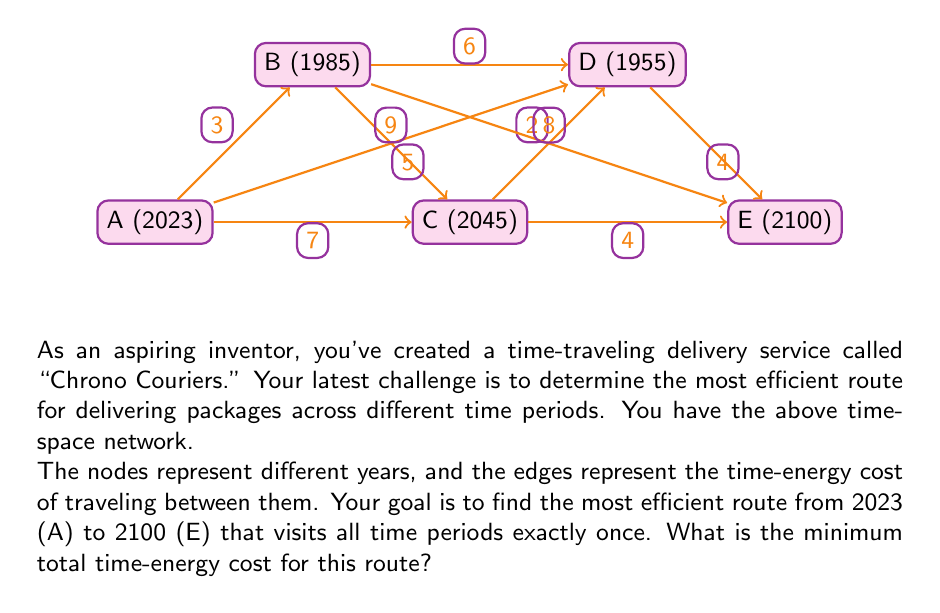Can you answer this question? To solve this problem, we need to find the Hamiltonian path with the minimum cost from A to E that visits all nodes exactly once. This is a variation of the Traveling Salesman Problem (TSP).

Given the small number of nodes, we can solve this using a brute-force approach by examining all possible paths:

1. List all possible paths from A to E visiting all nodes:
   - A -> B -> C -> D -> E
   - A -> B -> D -> C -> E
   - A -> C -> B -> D -> E
   - A -> C -> D -> B -> E
   - A -> D -> B -> C -> E
   - A -> D -> C -> B -> E

2. Calculate the cost for each path:
   - A -> B -> C -> D -> E: 3 + 5 + 2 + 4 = 14
   - A -> B -> D -> C -> E: 3 + 6 + 2 + 4 = 15
   - A -> C -> B -> D -> E: 7 + 5 + 6 + 4 = 22
   - A -> C -> D -> B -> E: 7 + 2 + 6 + 8 = 23
   - A -> D -> B -> C -> E: 9 + 6 + 5 + 4 = 24
   - A -> D -> C -> B -> E: 9 + 2 + 5 + 8 = 24

3. Identify the path with the minimum cost:
   The path A -> B -> C -> D -> E has the lowest cost of 14.

Therefore, the most efficient route for the Chrono Couriers service is to travel from 2023 to 1985, then to 2045, followed by 1955, and finally to 2100. This route minimizes the total time-energy cost.
Answer: 14 